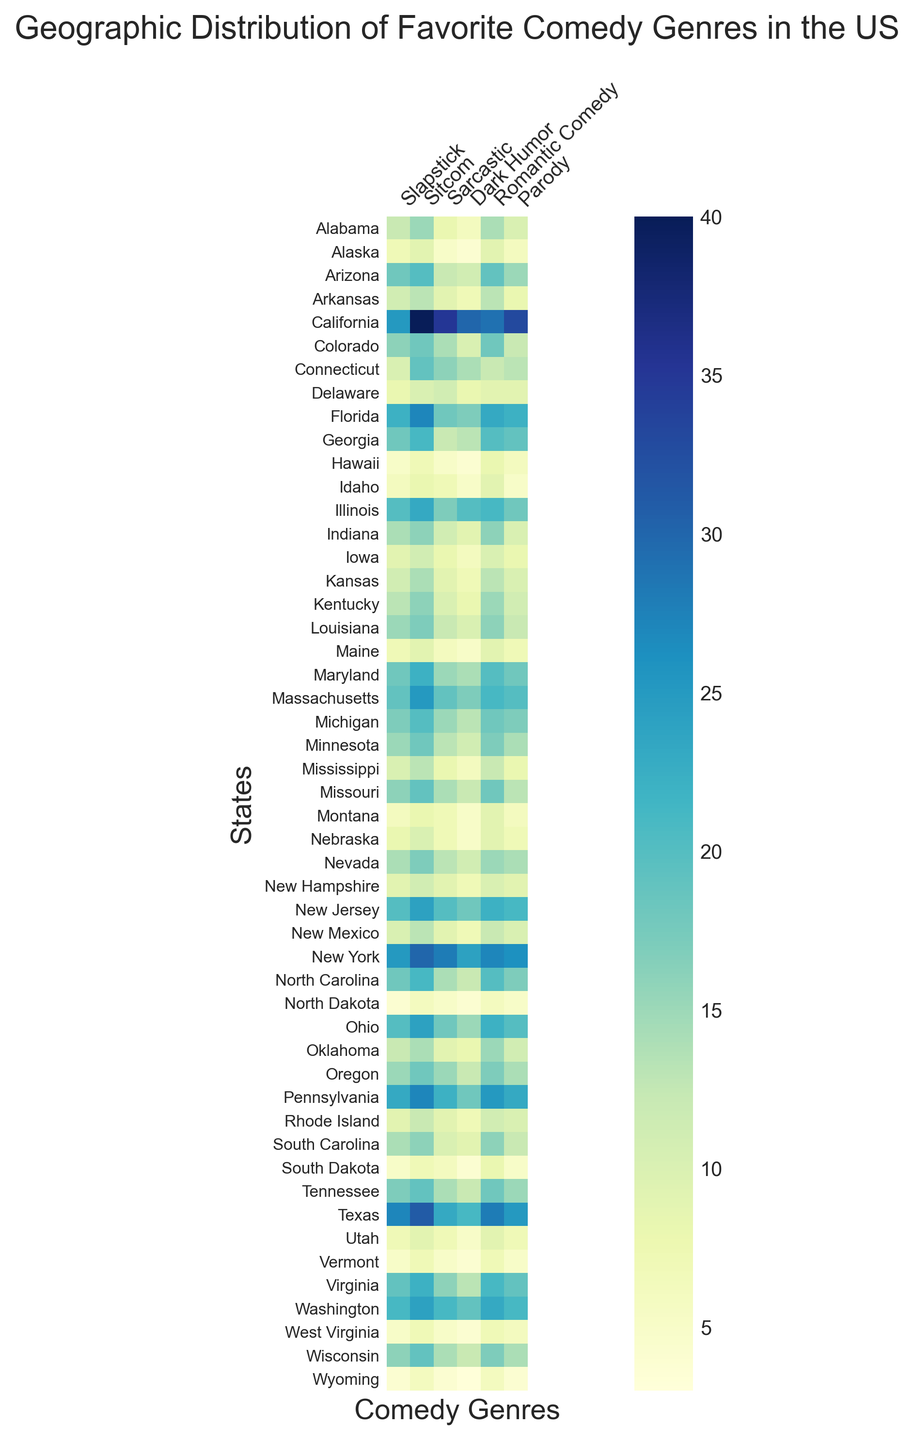Which state has the highest preference for Slapstick? By observing the darkest color in the "Slapstick" column, California stands out, as it has the highest value of 25 for this genre.
Answer: California Which two states have equal preference for Romantic Comedy? By finding the states with the same intensity of color in the "Romantic Comedy" column, Delaware and Idaho both show a value of 9.
Answer: Delaware and Idaho What's the average preference for Sitcoms across Texas, Florida, and California? The preference values for Sitcoms are 31 (Texas), 27 (Florida), and 40 (California). The sum is 31 + 27 + 40 = 98. The average is 98/3 ≈ 32.67.
Answer: ≈ 32.67 Is the preference for Sarcastic higher in New York or New Jersey? By comparing the values in the "Sarcastic" column, New York has a value of 28 and New Jersey has a value of 20. Therefore, New York has a higher preference for Sarcastic comedy.
Answer: New York Which state shows the lowest preference for Parody? The state with the lightest color in the "Parody" column is Wyoming, showing the lowest value of 4.
Answer: Wyoming What's the median preference for Slapstick in the states of Michigan, Minnesota, Missouri, and Montana? The values for Slapstick are 17 (Michigan), 15 (Minnesota), 16 (Missouri), and 6 (Montana). Arranging them in order: 6, 15, 16, 17. The median value is (15 + 16)/2 = 15.5.
Answer: 15.5 Is the preference for Dark Humor in Illinois greater than in Indiana? By comparing the values in the "Dark Humor" column, Illinois has a value of 20 and Indiana has a value of 9. Hence, the preference in Illinois is higher.
Answer: Yes Which genre is the most liked in Alabama? By observing the darkest color in the row for Alabama, Sitcom is the most preferred genre with a value of 15.
Answer: Sitcom Which state has an equal preference for Sitcom and Parody? By checking for states with matching values in both the "Sitcom" and "Parody" columns, Hawaii shows equal preference of 6 for both.
Answer: Hawaii 